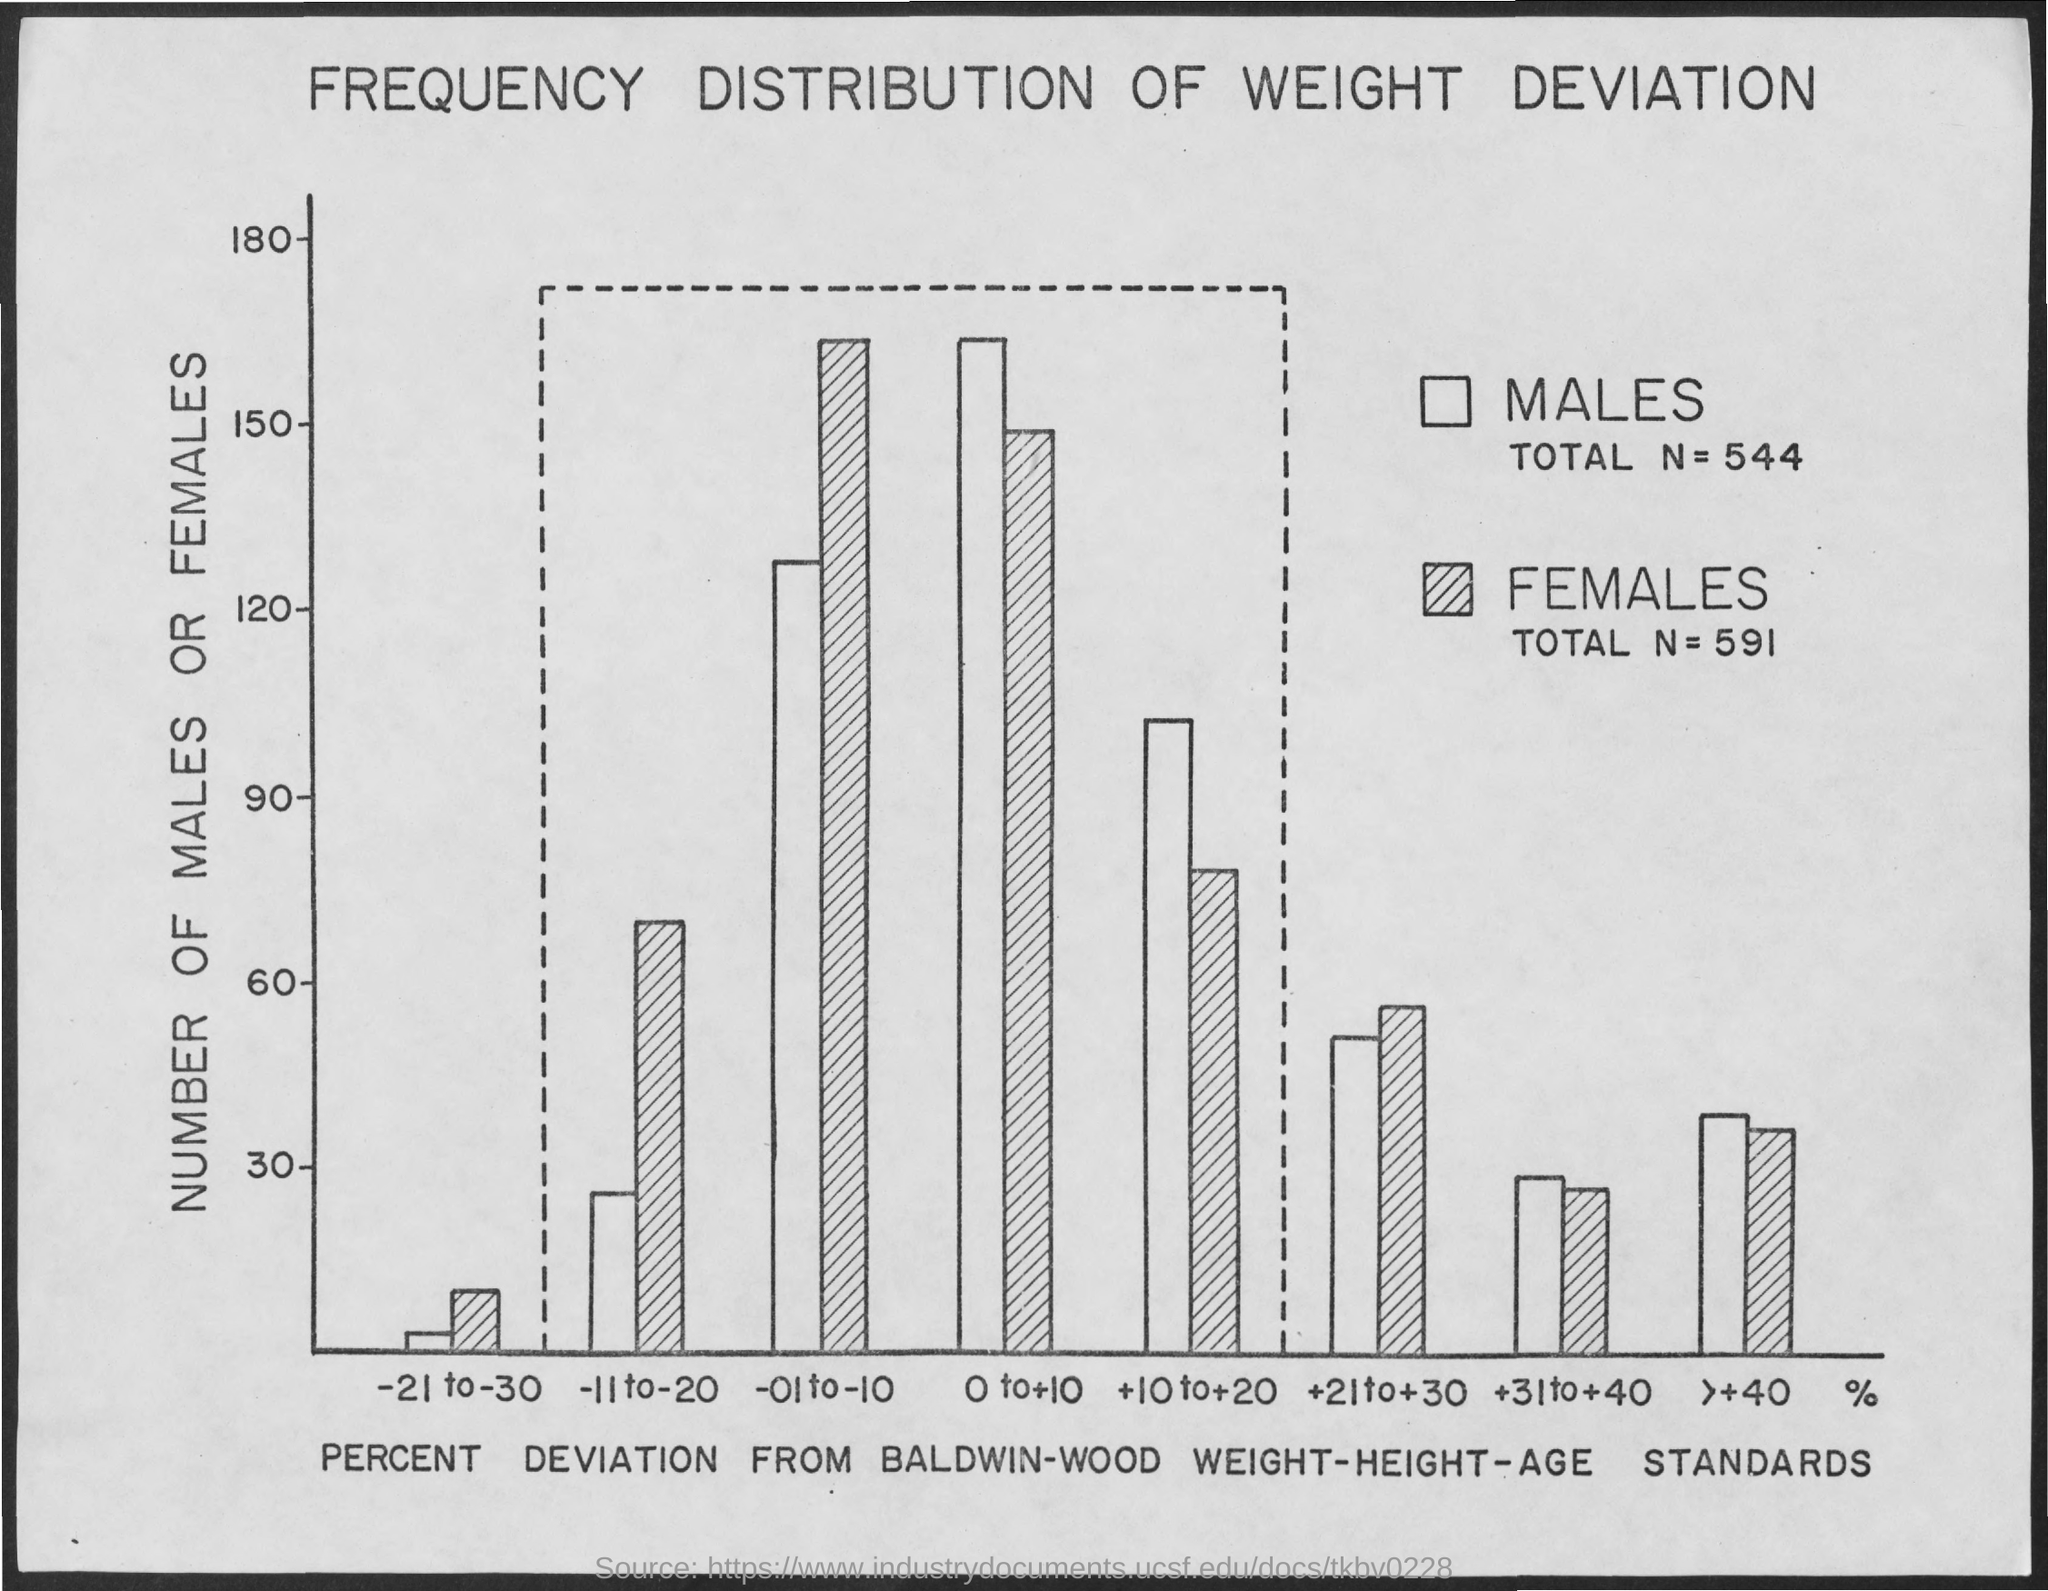What is the title of the graph shown?
Make the answer very short. FREQUENCY DISTRIBUTION OF WEIGHT DEVIATION. What does x-axis of the graph represent?
Make the answer very short. PERCENT DEVIATION FROM BALDWIN-WOOD WEIGHT-HEIGHT-AGE STANDARDS. What does y-axis of the graph represent?
Keep it short and to the point. NUMBER OF MALES OR FEMALES. What is the total no of males?
Offer a terse response. TOTAL N = 544. What is the total no of females?
Offer a terse response. TOTAL N = 591. 